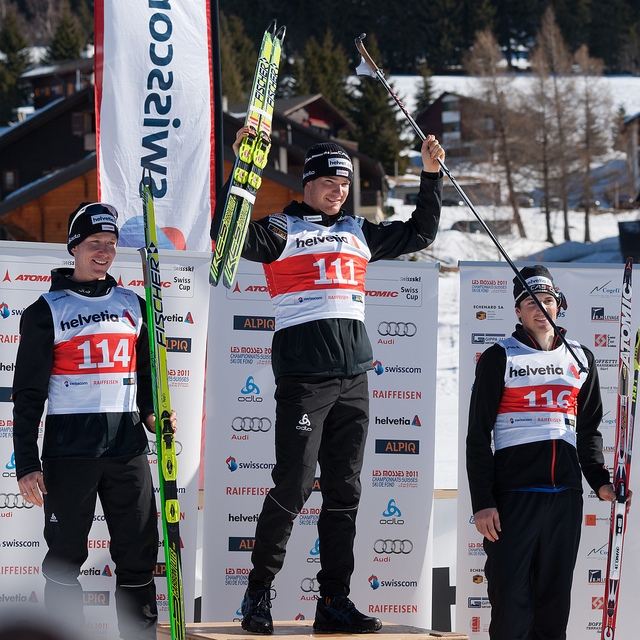What details can you infer about the type of sporting event these athletes are participating in? Given the attire of the athletes, the ski equipment they're holding, and the snowy background, it's evident that this is a winter sporting event, most likely a ski competition. Each athlete wears a bib with a number, suggesting they have completed a competitive race or event, and their standings are reflected by their positions on the podium. The sponsor logos suggest that it is a professionally organized event likely to attract competitors at a high skill level, potentially even at a national or international scale. 